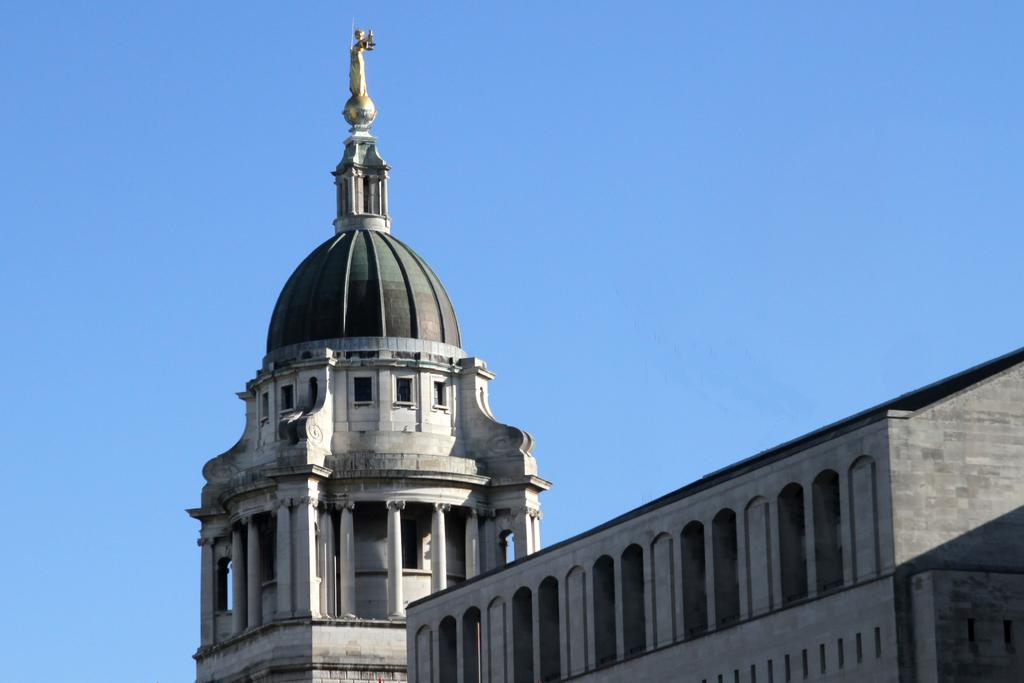What type of structure is present in the image? There is a building in the image. What colors are used for the building? The building is in white and gray colors. What can be seen in the background of the image? The sky is visible in the background of the image. What is the color of the sky in the image? The sky is blue in color. Are there any family members visible in the image? There is no indication of family members in the image; it primarily features a building and the sky. Can you see any skateboarders or skateboards in the image? There is no mention of skateboarders or skateboards in the image; it focuses on a building and the sky. 